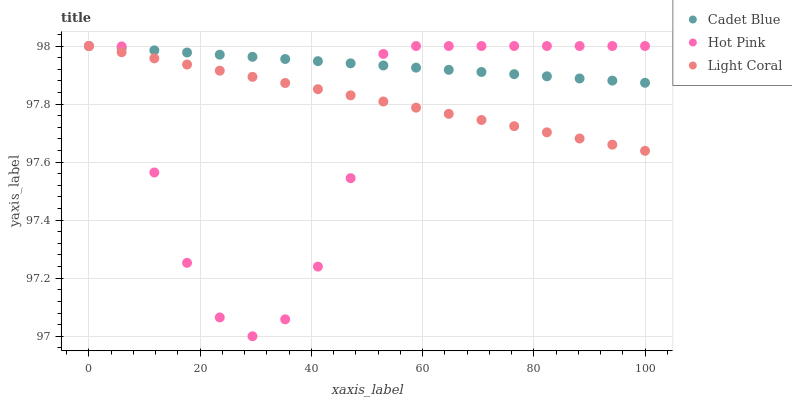Does Hot Pink have the minimum area under the curve?
Answer yes or no. Yes. Does Cadet Blue have the maximum area under the curve?
Answer yes or no. Yes. Does Cadet Blue have the minimum area under the curve?
Answer yes or no. No. Does Hot Pink have the maximum area under the curve?
Answer yes or no. No. Is Light Coral the smoothest?
Answer yes or no. Yes. Is Hot Pink the roughest?
Answer yes or no. Yes. Is Cadet Blue the smoothest?
Answer yes or no. No. Is Cadet Blue the roughest?
Answer yes or no. No. Does Hot Pink have the lowest value?
Answer yes or no. Yes. Does Cadet Blue have the lowest value?
Answer yes or no. No. Does Hot Pink have the highest value?
Answer yes or no. Yes. Does Hot Pink intersect Cadet Blue?
Answer yes or no. Yes. Is Hot Pink less than Cadet Blue?
Answer yes or no. No. Is Hot Pink greater than Cadet Blue?
Answer yes or no. No. 